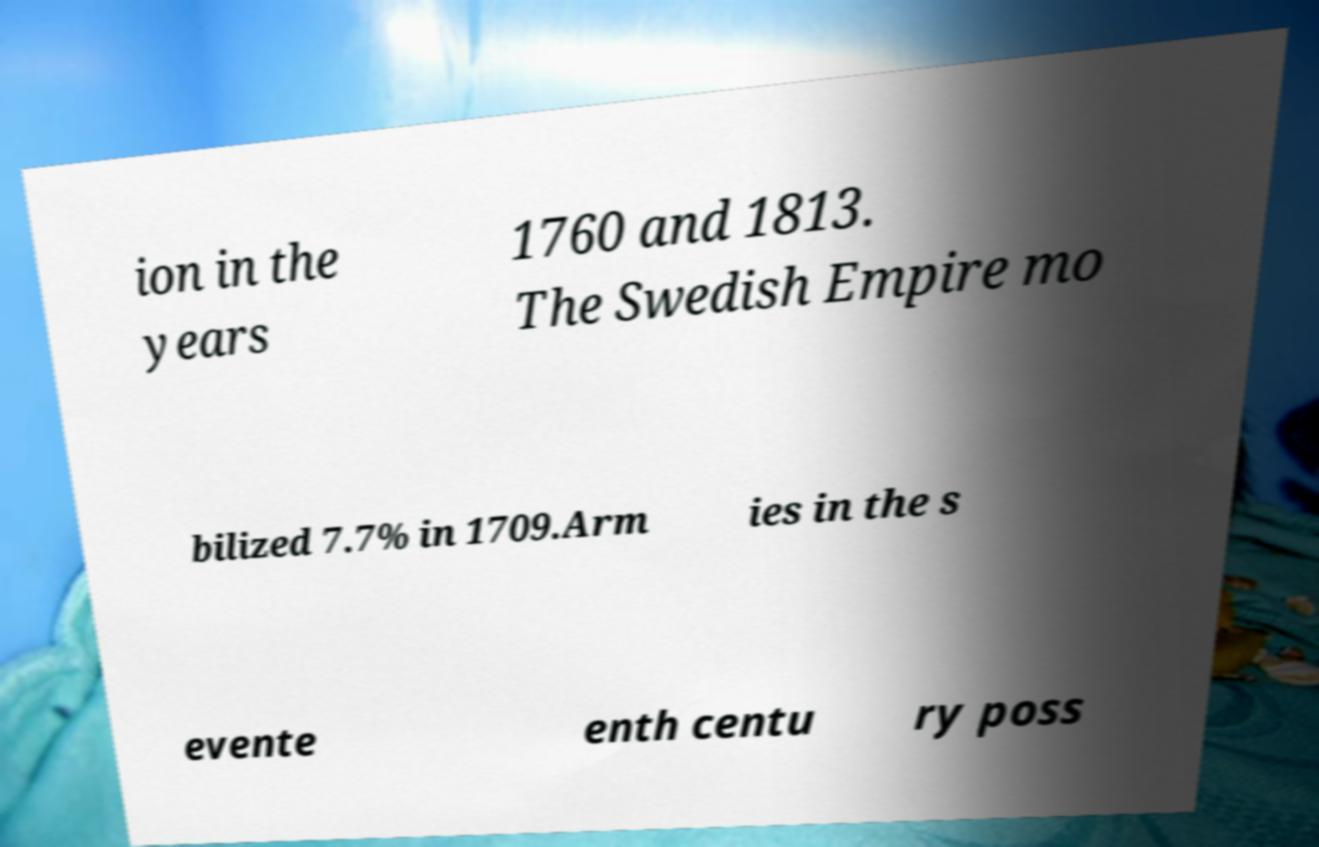What messages or text are displayed in this image? I need them in a readable, typed format. ion in the years 1760 and 1813. The Swedish Empire mo bilized 7.7% in 1709.Arm ies in the s evente enth centu ry poss 